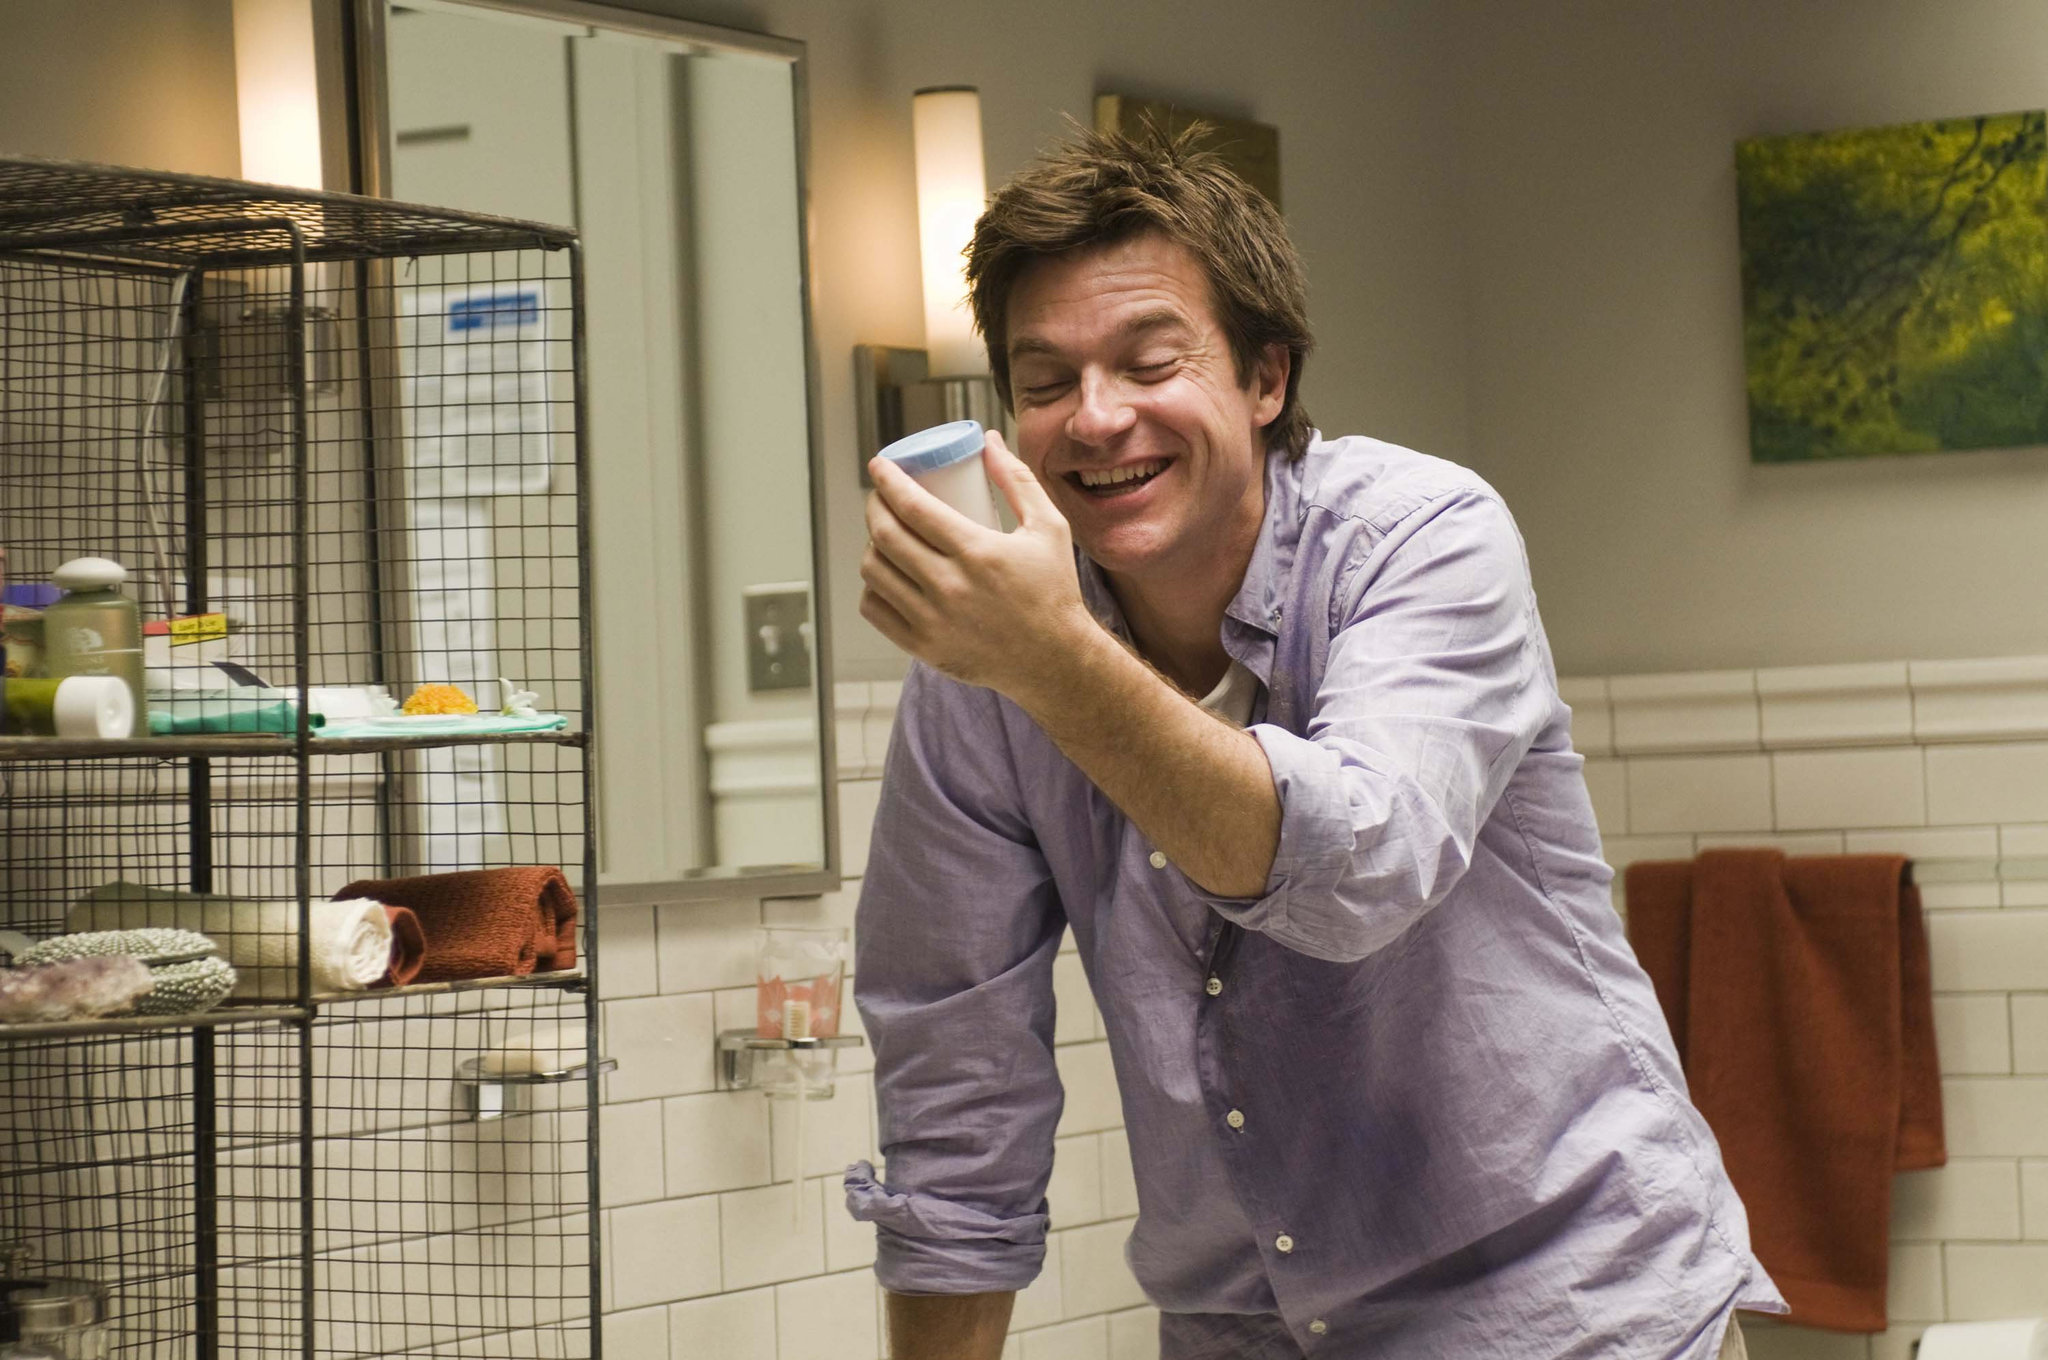What is the man in the picture thinking about? It's hard to say exactly what the man is thinking, but his joyous expression suggests he might be reminiscing about a funny memory or enjoying a moment of relaxation and amusement. Why do you think there's a birdcage in the bathroom? The presence of a birdcage in the bathroom is quite unusual and sparks curiosity. It might indicate that the man loves having his pet bird close by at all times, even in the bathroom, or it could be a whimsical choice to add a unique element to the decor. Alternatively, the birdcage could be temporarily placed there while cleaning or rearranging other parts of the house. 